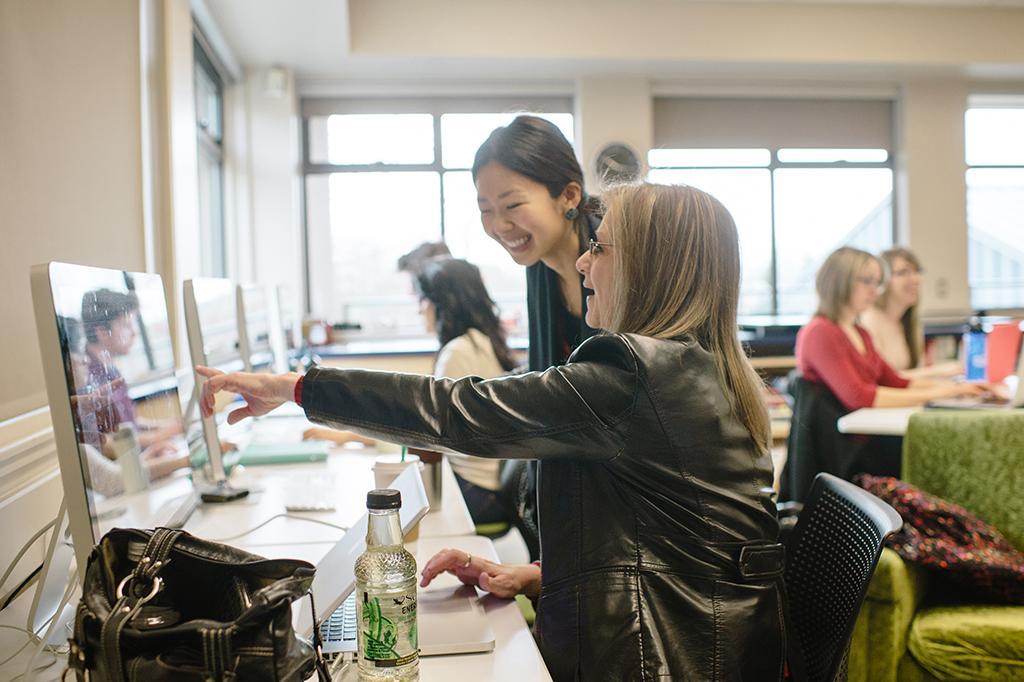In one or two sentences, can you explain what this image depicts? In this image i can see a inside view of building. And the right side of the image two girls sitting on the chair. One girl wearing red color jacket and another girl wearing white color jacket they both are kept hands on the table and green color carpet kept on the table. And back side of a white color jacket girl there is a window. On the middle i can see a two girls, one girl stand wearing a black color scarf and another girl wearing a black color jacket she also wearing a spectacles. on the left side i can a table. On the table i can see displays of the computer and handbag and a bottle. on the table i can a paper. On the left side there is wall visible. and on the middle corner there is a clock attached to the wall. And on the right corner there is a couch and on the couch there is a pillow. 